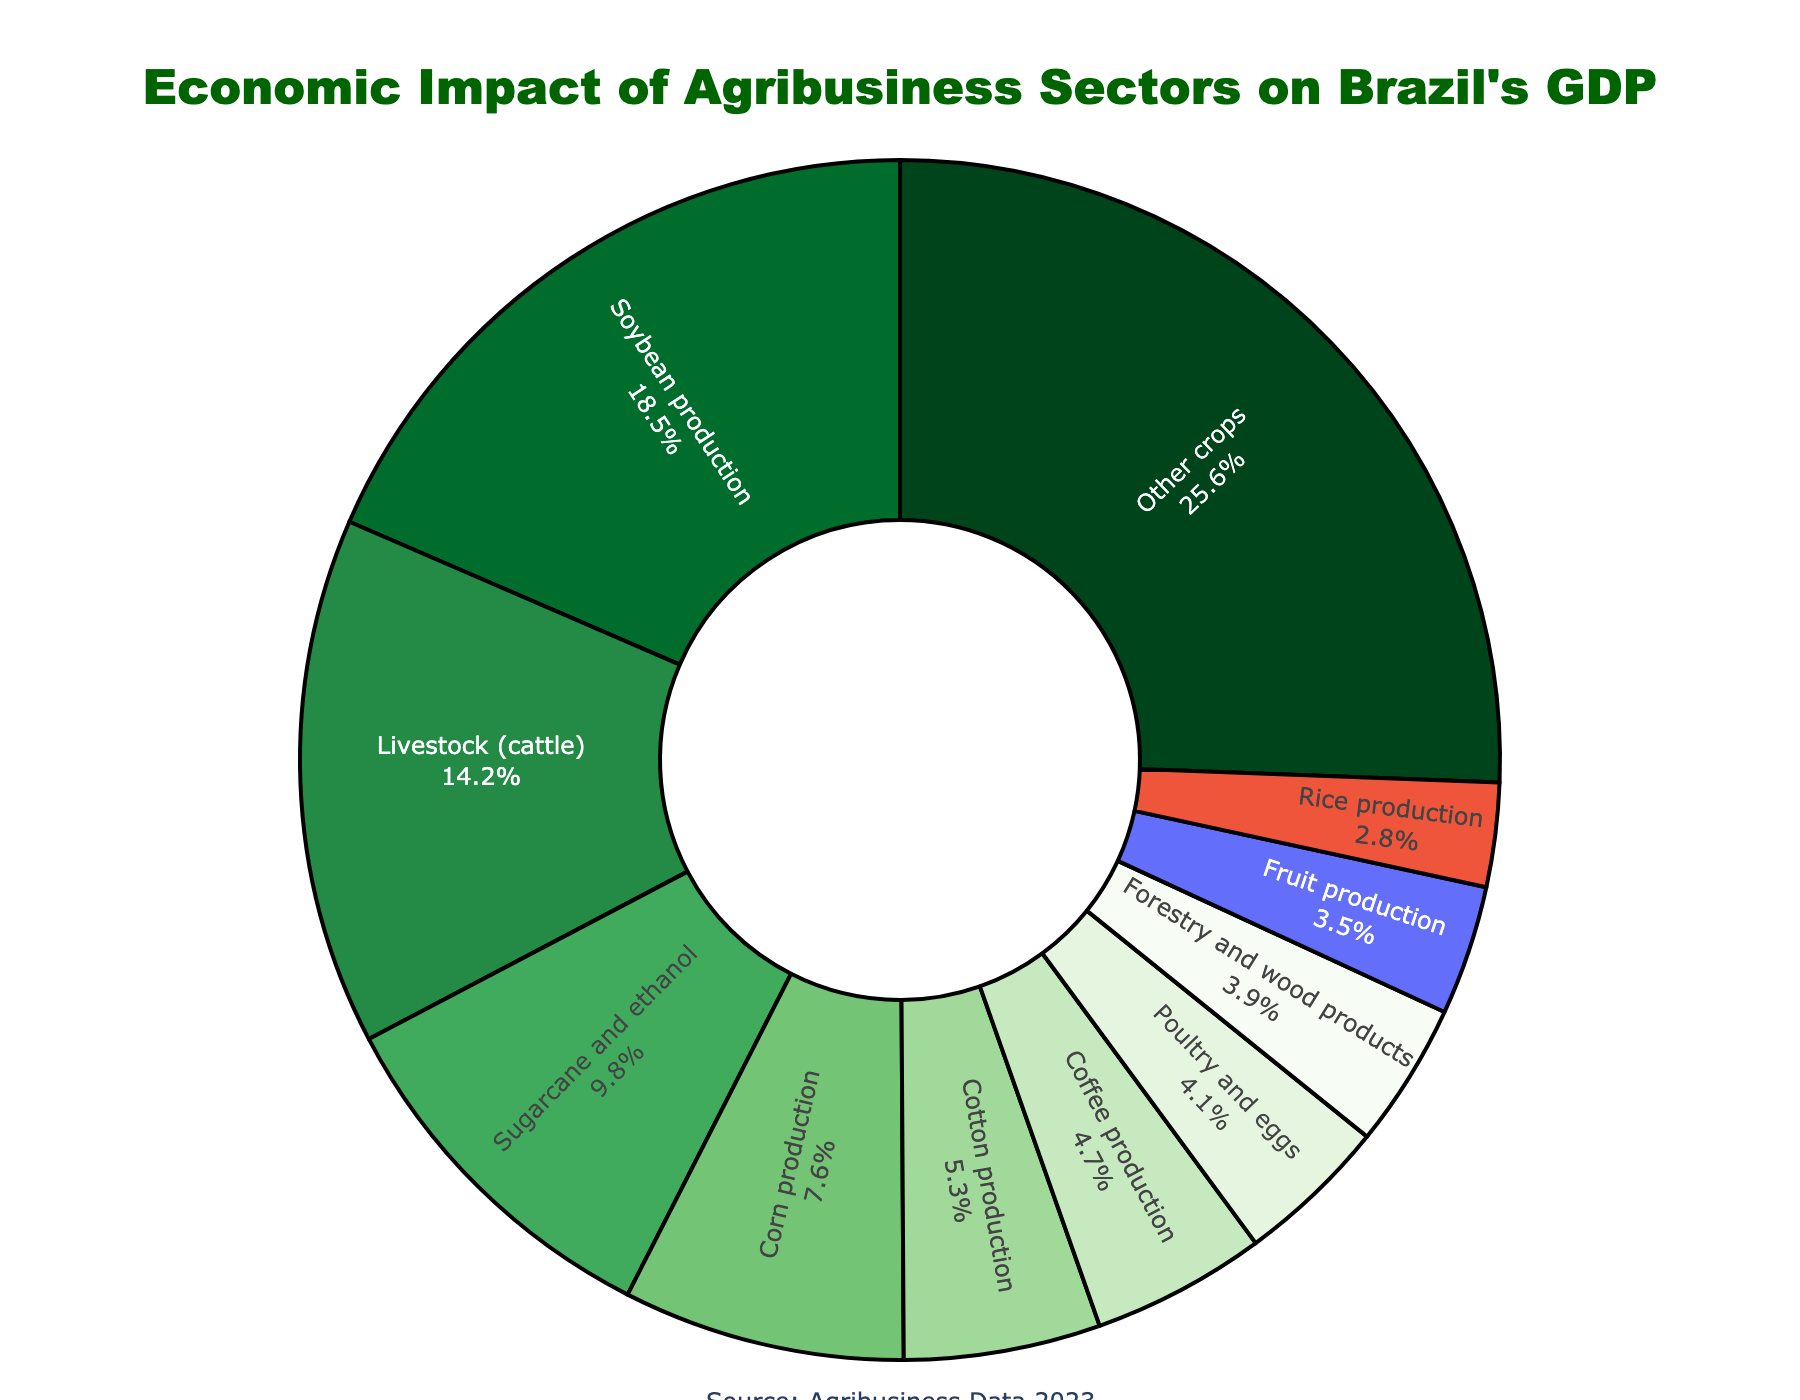What percentage of Brazil's GDP is contributed by Livestock (cattle)? Locate the label for "Livestock (cattle)" on the pie chart. Read the corresponding percentage value.
Answer: 14.2% Which sector has the highest impact on Brazil's GDP and what is its percentage contribution? Identify the largest segment in the pie chart. Read its label and percentage value.
Answer: Soybean production, 18.5% How much total percentage do Soybean production and Corn production contribute together? Read the percentages for Soybean production and Corn production. Add them together: 18.5% + 7.6% = 26.1%.
Answer: 26.1% Is the contribution of Fruit production greater than that of Coffee production? Locate the segments for Fruit production and Coffee production on the pie chart. Compare their percentages (3.5% for Fruit production and 4.7% for Coffee production).
Answer: No What is the sum of the contributions of Poultry and eggs and Cotton production? Find the percentages for Poultry and eggs and Cotton production. Add them together: 4.1% + 5.3% = 9.4%.
Answer: 9.4% Does Rice production contribute more than 3% to Brazil's GDP? Locate the Rice production segment on the pie chart. Check its percentage (2.8%) and see if it is more than 3%.
Answer: No What percentage do the "Other crops" account for in Brazil's GDP? Find the segment labeled "Other crops" on the pie chart and read the percentage value associated with it.
Answer: 25.6% Is the combined contribution of Forestry and wood products and Sugarcane and ethanol greater than 13%? Read the percentages for Forestry and wood products (3.9%) and Sugarcane and ethanol (9.8%). Add them together: 3.9% + 9.8% = 13.7%. Compare with 13%.
Answer: Yes Which sector contributes less to the GDP, Poultry and eggs or Rice production? Identify the segments for Poultry and eggs (4.1%) and Rice production (2.8%). Compare their percentages.
Answer: Rice production How does the percentage of Coffee production compare to that of Cotton production? Locate the segments for Coffee production (4.7%) and Cotton production (5.3%). Compare their percentages.
Answer: Coffee production is less than Cotton production 